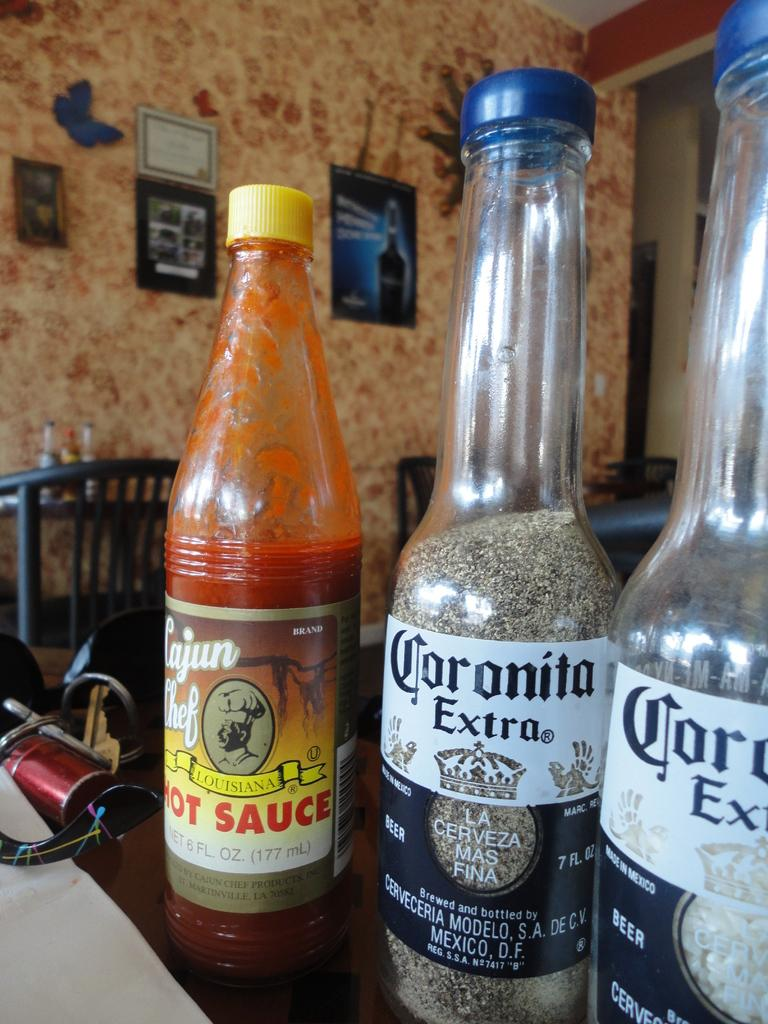<image>
Summarize the visual content of the image. A bottle of Cajun Chef hot sauce and Coronita Extra bottles of salt and pepper. 